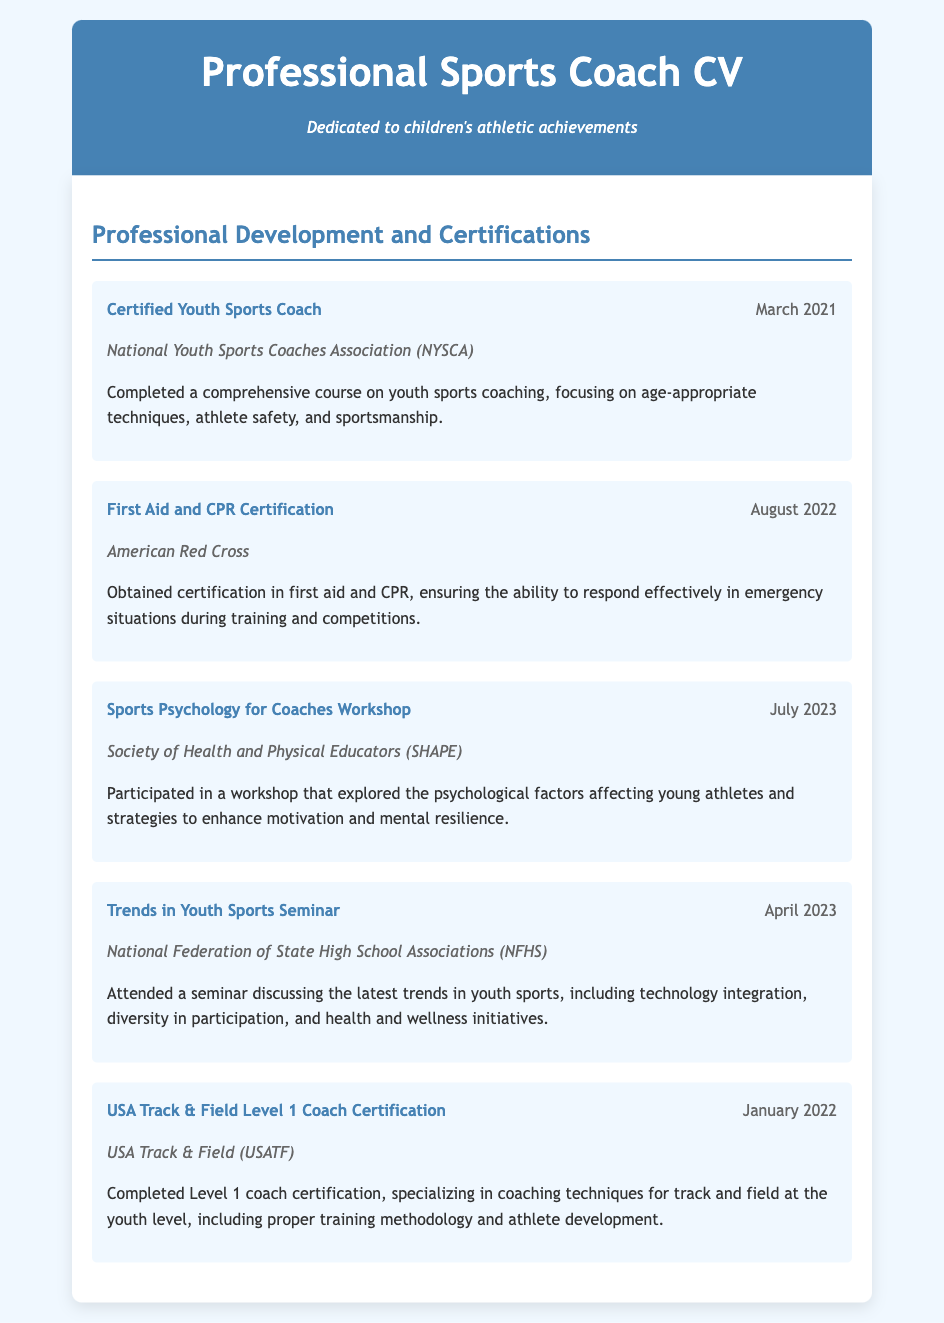What is the most recent certification obtained? The most recent certification listed in the document is from July 2023, which is the Sports Psychology for Coaches Workshop.
Answer: Sports Psychology for Coaches Workshop Who issued the Certified Youth Sports Coach certification? The certification was issued by the National Youth Sports Coaches Association (NYSCA).
Answer: National Youth Sports Coaches Association (NYSCA) When did the Trends in Youth Sports Seminar take place? The seminar took place in April 2023, as noted in the document.
Answer: April 2023 What type of certification is obtained from the American Red Cross? The certification from the American Red Cross is related to first aid and CPR.
Answer: First Aid and CPR Certification What does the USA Track & Field Level 1 Coach Certification specialize in? It specializes in coaching techniques for track and field at the youth level.
Answer: Coaching techniques for track and field at the youth level Which organization conducted the Sports Psychology for Coaches Workshop? The workshop was conducted by the Society of Health and Physical Educators (SHAPE).
Answer: Society of Health and Physical Educators (SHAPE) How many certifications were obtained in 2021? Only one certification was obtained in 2021, which is the Certified Youth Sports Coach.
Answer: One 